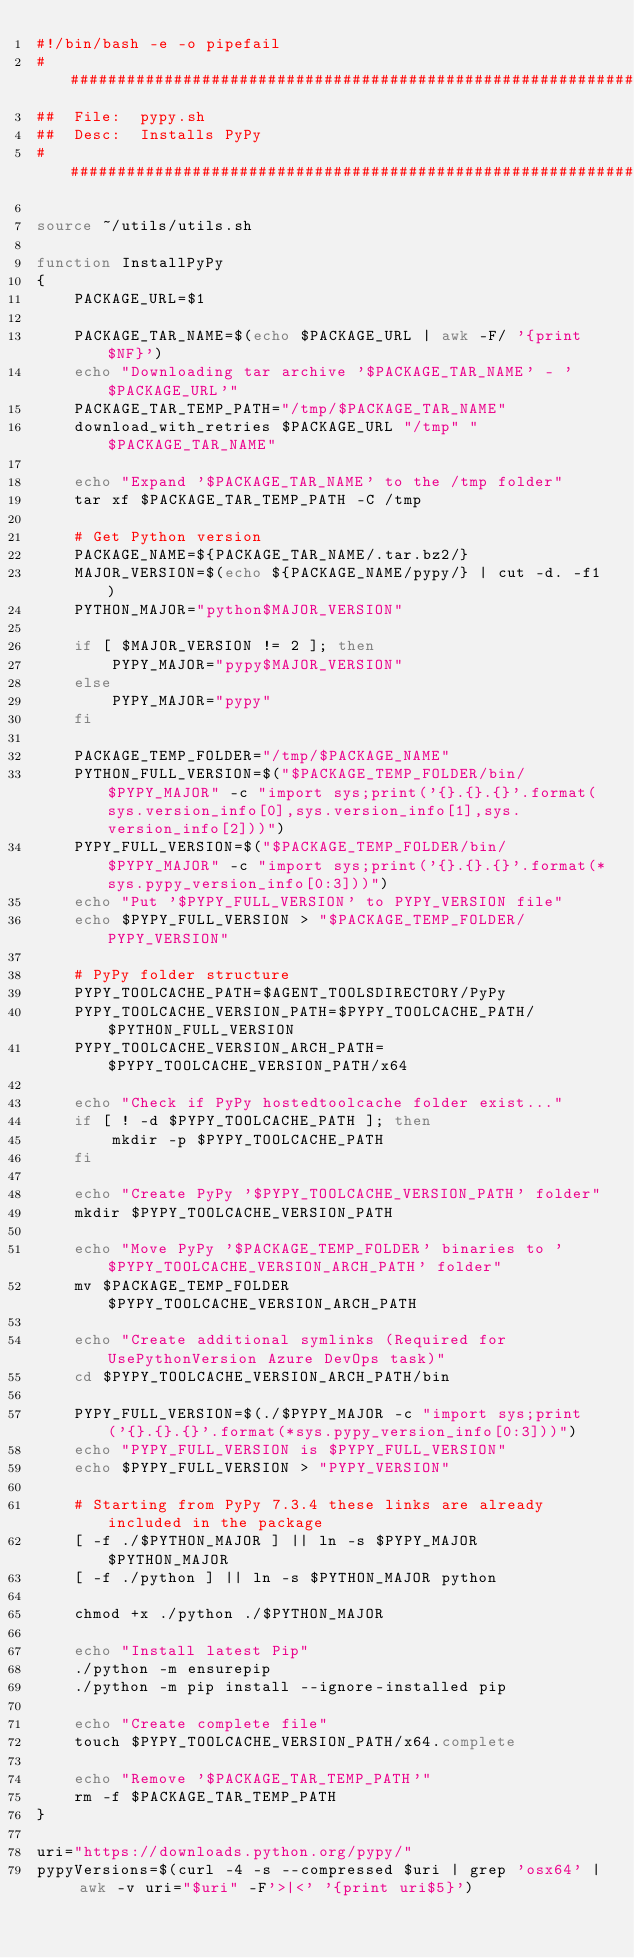<code> <loc_0><loc_0><loc_500><loc_500><_Bash_>#!/bin/bash -e -o pipefail
################################################################################
##  File:  pypy.sh
##  Desc:  Installs PyPy
################################################################################

source ~/utils/utils.sh

function InstallPyPy
{
    PACKAGE_URL=$1

    PACKAGE_TAR_NAME=$(echo $PACKAGE_URL | awk -F/ '{print $NF}')
    echo "Downloading tar archive '$PACKAGE_TAR_NAME' - '$PACKAGE_URL'"
    PACKAGE_TAR_TEMP_PATH="/tmp/$PACKAGE_TAR_NAME"
    download_with_retries $PACKAGE_URL "/tmp" "$PACKAGE_TAR_NAME"

    echo "Expand '$PACKAGE_TAR_NAME' to the /tmp folder"
    tar xf $PACKAGE_TAR_TEMP_PATH -C /tmp

    # Get Python version
    PACKAGE_NAME=${PACKAGE_TAR_NAME/.tar.bz2/}
    MAJOR_VERSION=$(echo ${PACKAGE_NAME/pypy/} | cut -d. -f1)
    PYTHON_MAJOR="python$MAJOR_VERSION"

    if [ $MAJOR_VERSION != 2 ]; then
        PYPY_MAJOR="pypy$MAJOR_VERSION"
    else
        PYPY_MAJOR="pypy"
    fi

    PACKAGE_TEMP_FOLDER="/tmp/$PACKAGE_NAME"
    PYTHON_FULL_VERSION=$("$PACKAGE_TEMP_FOLDER/bin/$PYPY_MAJOR" -c "import sys;print('{}.{}.{}'.format(sys.version_info[0],sys.version_info[1],sys.version_info[2]))")
    PYPY_FULL_VERSION=$("$PACKAGE_TEMP_FOLDER/bin/$PYPY_MAJOR" -c "import sys;print('{}.{}.{}'.format(*sys.pypy_version_info[0:3]))")
    echo "Put '$PYPY_FULL_VERSION' to PYPY_VERSION file"
    echo $PYPY_FULL_VERSION > "$PACKAGE_TEMP_FOLDER/PYPY_VERSION"

    # PyPy folder structure
    PYPY_TOOLCACHE_PATH=$AGENT_TOOLSDIRECTORY/PyPy
    PYPY_TOOLCACHE_VERSION_PATH=$PYPY_TOOLCACHE_PATH/$PYTHON_FULL_VERSION
    PYPY_TOOLCACHE_VERSION_ARCH_PATH=$PYPY_TOOLCACHE_VERSION_PATH/x64

    echo "Check if PyPy hostedtoolcache folder exist..."
    if [ ! -d $PYPY_TOOLCACHE_PATH ]; then
        mkdir -p $PYPY_TOOLCACHE_PATH
    fi

    echo "Create PyPy '$PYPY_TOOLCACHE_VERSION_PATH' folder"
    mkdir $PYPY_TOOLCACHE_VERSION_PATH

    echo "Move PyPy '$PACKAGE_TEMP_FOLDER' binaries to '$PYPY_TOOLCACHE_VERSION_ARCH_PATH' folder"
    mv $PACKAGE_TEMP_FOLDER $PYPY_TOOLCACHE_VERSION_ARCH_PATH

    echo "Create additional symlinks (Required for UsePythonVersion Azure DevOps task)"
    cd $PYPY_TOOLCACHE_VERSION_ARCH_PATH/bin

    PYPY_FULL_VERSION=$(./$PYPY_MAJOR -c "import sys;print('{}.{}.{}'.format(*sys.pypy_version_info[0:3]))")
    echo "PYPY_FULL_VERSION is $PYPY_FULL_VERSION"
    echo $PYPY_FULL_VERSION > "PYPY_VERSION"

    # Starting from PyPy 7.3.4 these links are already included in the package
    [ -f ./$PYTHON_MAJOR ] || ln -s $PYPY_MAJOR $PYTHON_MAJOR
    [ -f ./python ] || ln -s $PYTHON_MAJOR python

    chmod +x ./python ./$PYTHON_MAJOR

    echo "Install latest Pip"
    ./python -m ensurepip
    ./python -m pip install --ignore-installed pip

    echo "Create complete file"
    touch $PYPY_TOOLCACHE_VERSION_PATH/x64.complete

    echo "Remove '$PACKAGE_TAR_TEMP_PATH'"
    rm -f $PACKAGE_TAR_TEMP_PATH
}

uri="https://downloads.python.org/pypy/"
pypyVersions=$(curl -4 -s --compressed $uri | grep 'osx64' | awk -v uri="$uri" -F'>|<' '{print uri$5}')</code> 